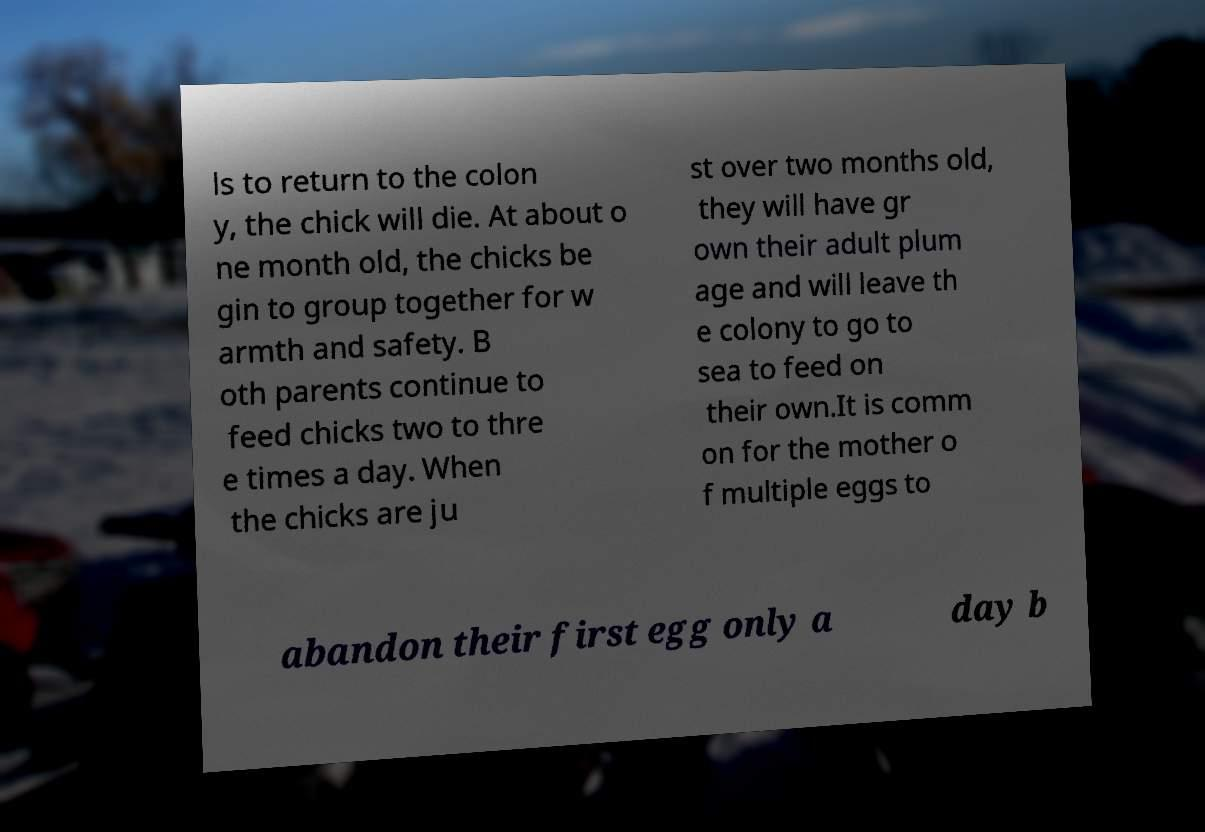Please identify and transcribe the text found in this image. ls to return to the colon y, the chick will die. At about o ne month old, the chicks be gin to group together for w armth and safety. B oth parents continue to feed chicks two to thre e times a day. When the chicks are ju st over two months old, they will have gr own their adult plum age and will leave th e colony to go to sea to feed on their own.It is comm on for the mother o f multiple eggs to abandon their first egg only a day b 